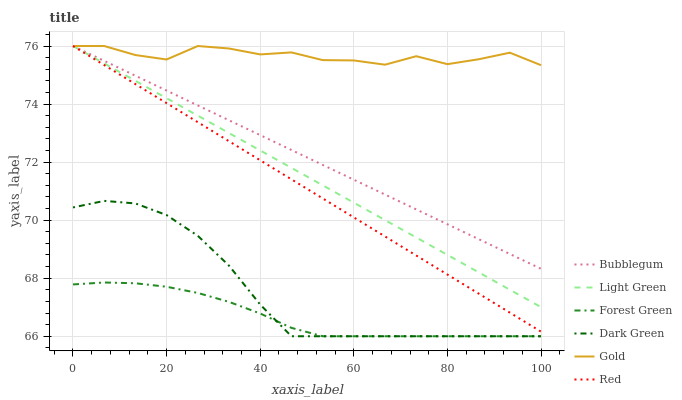Does Bubblegum have the minimum area under the curve?
Answer yes or no. No. Does Bubblegum have the maximum area under the curve?
Answer yes or no. No. Is Forest Green the smoothest?
Answer yes or no. No. Is Forest Green the roughest?
Answer yes or no. No. Does Bubblegum have the lowest value?
Answer yes or no. No. Does Forest Green have the highest value?
Answer yes or no. No. Is Forest Green less than Gold?
Answer yes or no. Yes. Is Gold greater than Dark Green?
Answer yes or no. Yes. Does Forest Green intersect Gold?
Answer yes or no. No. 